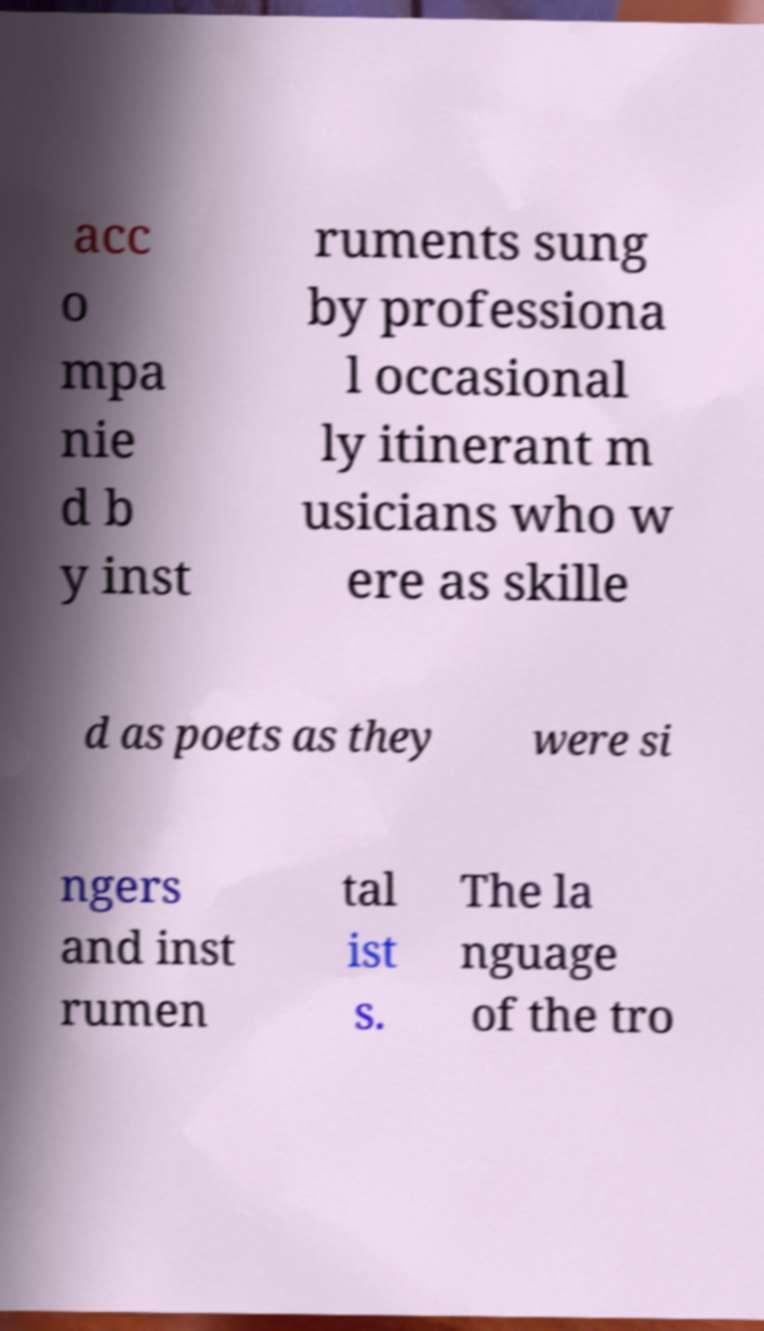Could you assist in decoding the text presented in this image and type it out clearly? acc o mpa nie d b y inst ruments sung by professiona l occasional ly itinerant m usicians who w ere as skille d as poets as they were si ngers and inst rumen tal ist s. The la nguage of the tro 